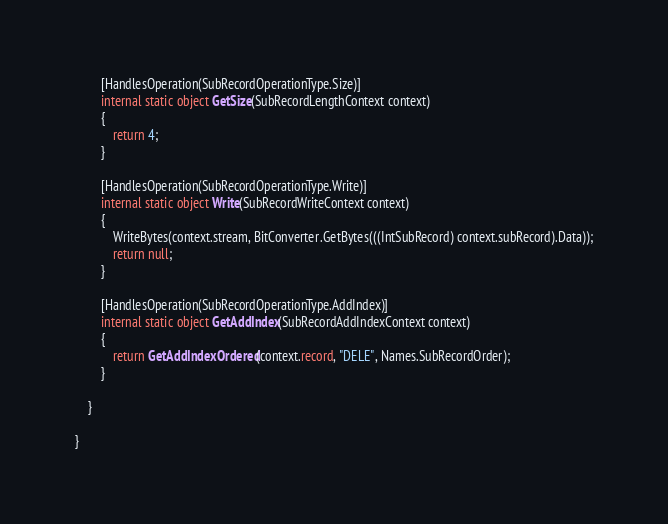<code> <loc_0><loc_0><loc_500><loc_500><_C#_>		[HandlesOperation(SubRecordOperationType.Size)]
		internal static object GetSize(SubRecordLengthContext context)
		{
            return 4;
		}
		
		[HandlesOperation(SubRecordOperationType.Write)]
		internal static object Write(SubRecordWriteContext context)
		{
            WriteBytes(context.stream, BitConverter.GetBytes(((IntSubRecord) context.subRecord).Data));
			return null;
		}
		
		[HandlesOperation(SubRecordOperationType.AddIndex)]
		internal static object GetAddIndex(SubRecordAddIndexContext context)
		{
			return GetAddIndexOrdered(context.record, "DELE", Names.SubRecordOrder);
		}
		
	}
	
}
</code> 